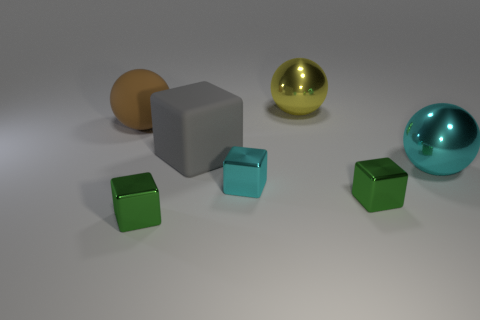Add 2 large gray blocks. How many objects exist? 9 Subtract all brown balls. How many balls are left? 2 Subtract all cyan shiny balls. How many balls are left? 2 Subtract 1 brown balls. How many objects are left? 6 Subtract all cubes. How many objects are left? 3 Subtract 3 spheres. How many spheres are left? 0 Subtract all purple cubes. Subtract all brown balls. How many cubes are left? 4 Subtract all cyan cylinders. How many gray spheres are left? 0 Subtract all brown things. Subtract all tiny green blocks. How many objects are left? 4 Add 5 gray matte things. How many gray matte things are left? 6 